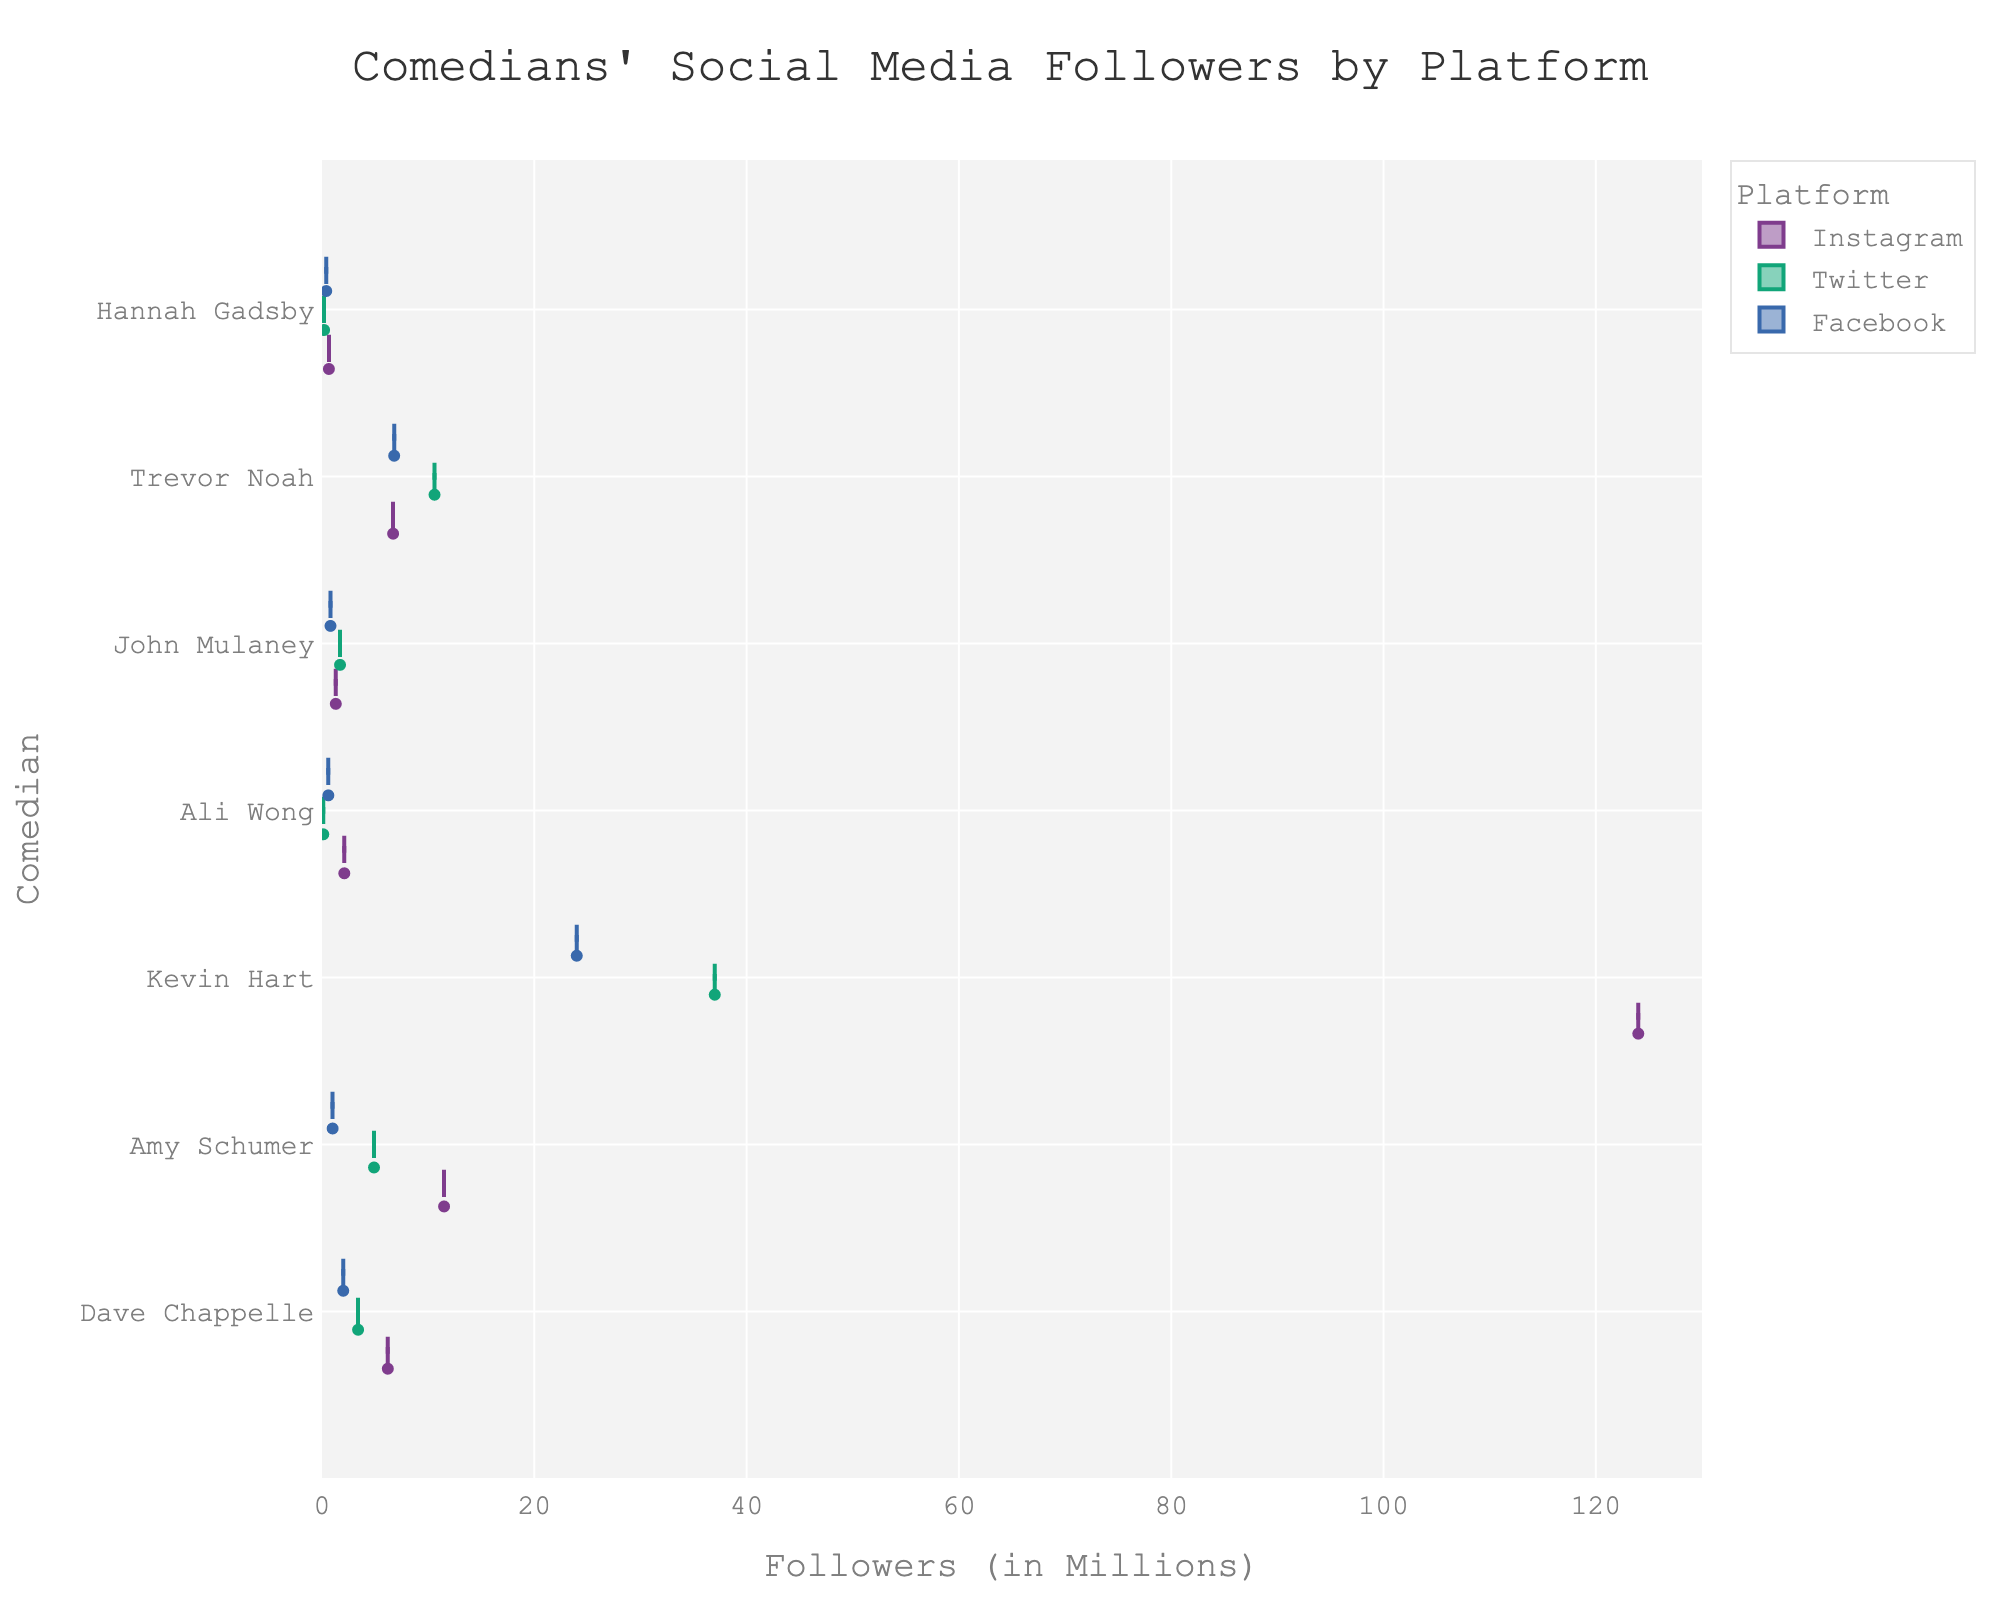What's the title of the chart? The title is prominently displayed at the top of the chart.
Answer: "Comedians' Social Media Followers by Platform" How many distinct social media platforms are represented in the chart? Each color in the violin plot represents a different platform and usually, a legend is provided for reference.
Answer: 3 Which comedian has the highest number of Instagram followers? By looking at the extend of the violin plots for each comedian in the "Instagram" color, it is apparent that Kevin Hart's violin plot extends the furthest.
Answer: Kevin Hart What is the approximate range of Twitter followers for Amy Schumer? Observing the range of Amy Schumer's violin plot for Twitter, you can see the whiskers of the box plot which extend from the minimum to the maximum value. In this case, it is from 4.9 million to 4.9 million since it's a single point box.
Answer: 4.9 million Does Dave Chappelle have more Facebook followers than Ali Wong? Comparing the lengths of the violin plots for Dave Chappelle and Ali Wong under the Facebook category, Dave Chappelle's plot is longer.
Answer: Yes Which comedian has the lowest number of followers on any platform and what is that number? By observing the shortest violin plot across all comedians and platforms, Hannah Gadsby on Twitter has the shortest plot.
Answer: Hannah Gadsby, 200,000 followers Compare the Instagram followers of Dave Chappelle and Trevor Noah. Who has more and by how much? Look at the lengths of the violin plots for Dave Chappelle and Trevor Noah under Instagram. Subtracting Dave's followers (6.2 million) from Trevor's (6.7 million) gives the difference.
Answer: Trevor Noah, 0.5 million Which comedian has the most balanced distribution of followers across platforms? By observing the violin plot widths for each comedian across all platforms, both John Mulaney and Hannah Gadsby have relatively narrow and similar plots across all platforms, indicating a more balanced distribution.
Answer: John Mulaney or Hannah Gadsby What is the total number of followers for Kevin Hart across all platforms? Sum the followers from Instagram (124 million), Twitter (37 million), and Facebook (24 million) as indicated by the end of each violin plot in respective colors.
Answer: 185 million Who has more Twitter followers, Trevor Noah or Kevin Hart? Compare the lengths of the violin plots for Trevor Noah and Kevin Hart under Twitter. Trevor Noah has a longer plot.
Answer: Trevor Noah 